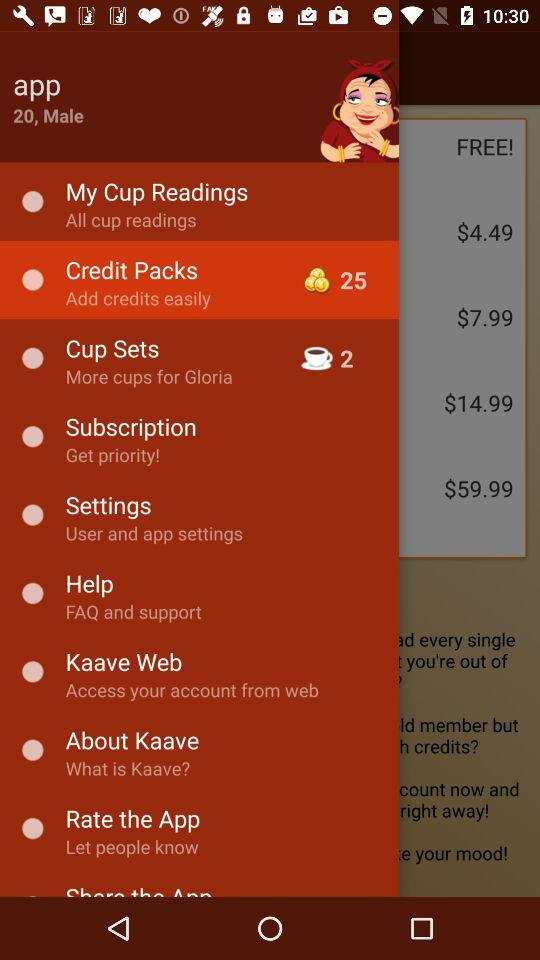How many years old is the user? The user is 20 years old. 